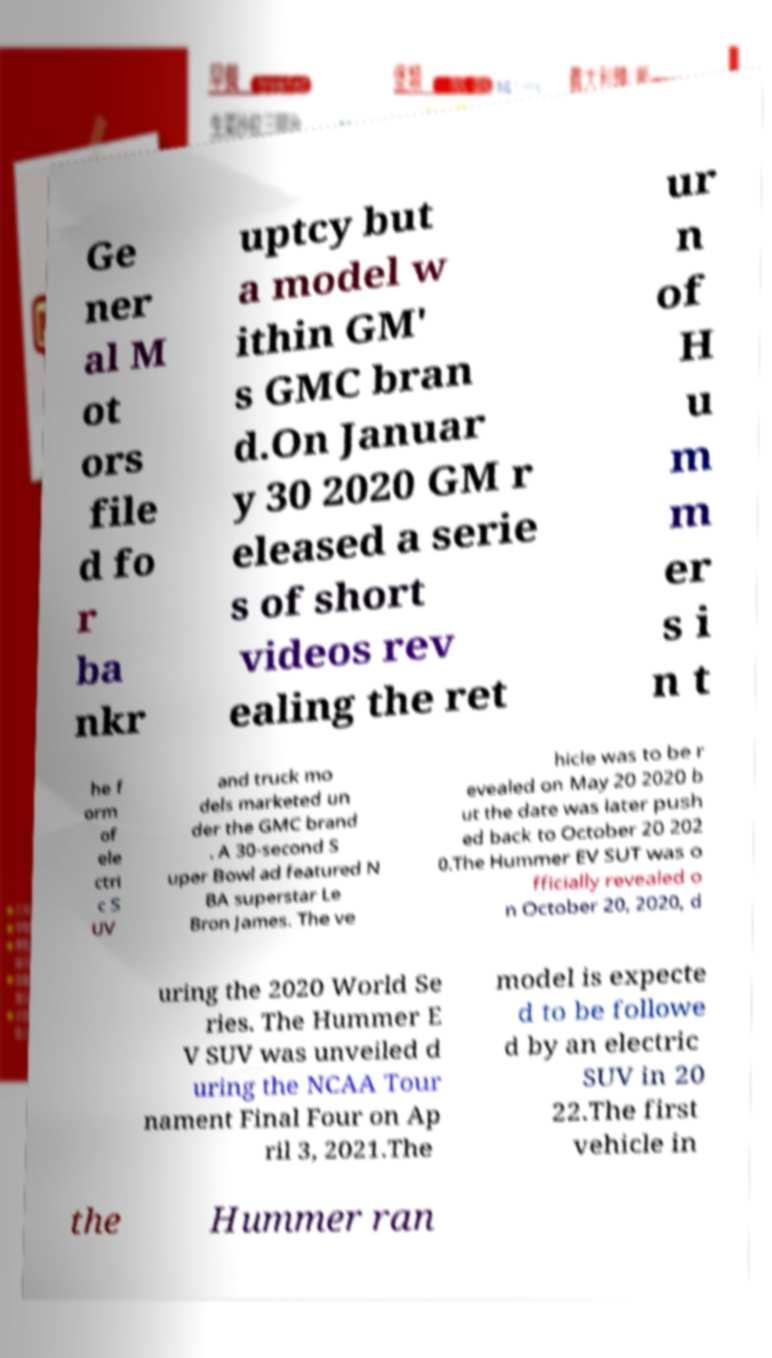Could you assist in decoding the text presented in this image and type it out clearly? Ge ner al M ot ors file d fo r ba nkr uptcy but a model w ithin GM' s GMC bran d.On Januar y 30 2020 GM r eleased a serie s of short videos rev ealing the ret ur n of H u m m er s i n t he f orm of ele ctri c S UV and truck mo dels marketed un der the GMC brand . A 30-second S uper Bowl ad featured N BA superstar Le Bron James. The ve hicle was to be r evealed on May 20 2020 b ut the date was later push ed back to October 20 202 0.The Hummer EV SUT was o fficially revealed o n October 20, 2020, d uring the 2020 World Se ries. The Hummer E V SUV was unveiled d uring the NCAA Tour nament Final Four on Ap ril 3, 2021.The model is expecte d to be followe d by an electric SUV in 20 22.The first vehicle in the Hummer ran 